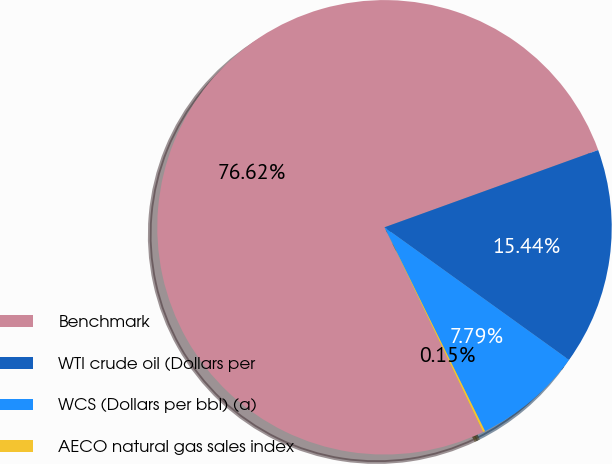<chart> <loc_0><loc_0><loc_500><loc_500><pie_chart><fcel>Benchmark<fcel>WTI crude oil (Dollars per<fcel>WCS (Dollars per bbl) (a)<fcel>AECO natural gas sales index<nl><fcel>76.62%<fcel>15.44%<fcel>7.79%<fcel>0.15%<nl></chart> 